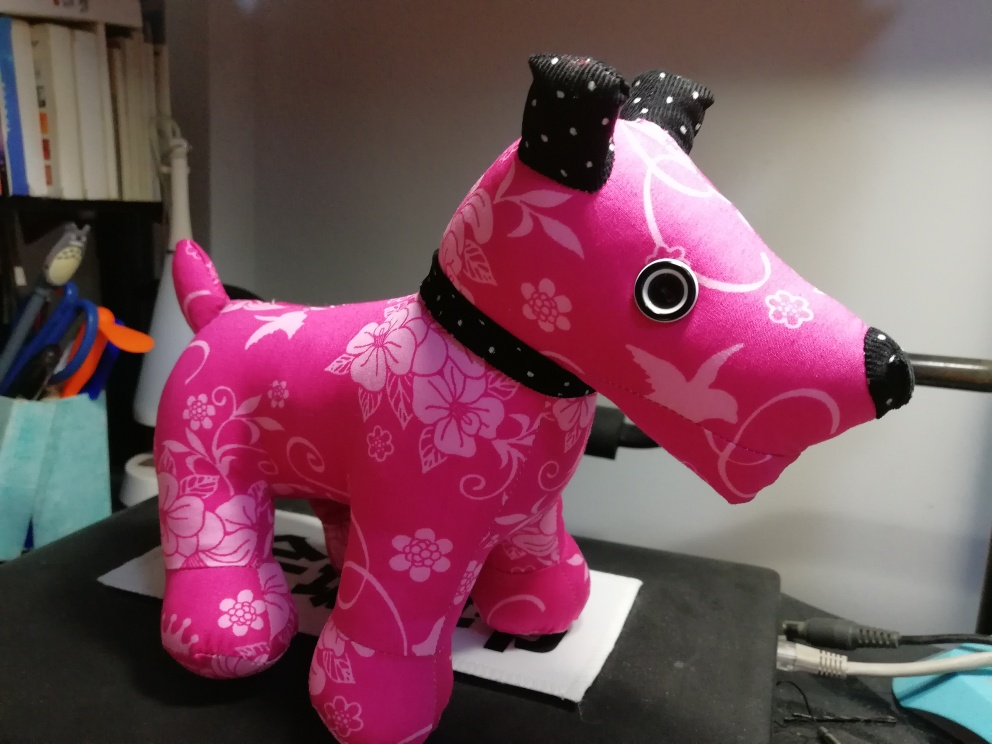What type of object is depicted in this image? The image shows a decorative object resembling a dog. It is styled with a vivid pink color adorned with floral patterns and has a black collar, giving it a playful and ornamental look. 